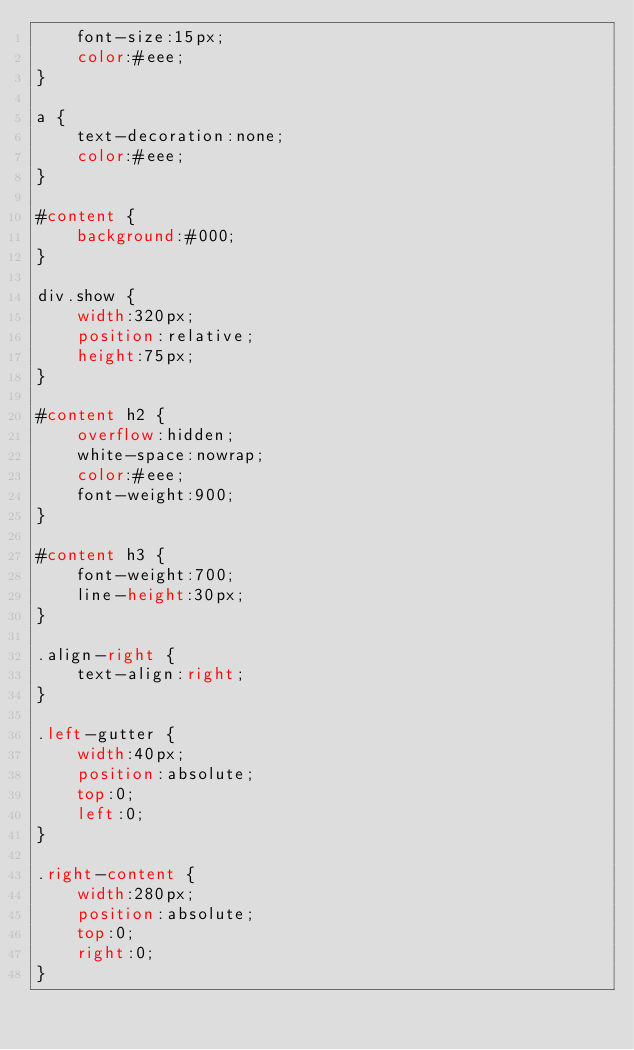<code> <loc_0><loc_0><loc_500><loc_500><_CSS_>    font-size:15px;
    color:#eee;
}

a {
    text-decoration:none;
    color:#eee;
}

#content {
    background:#000;
}

div.show {
    width:320px;
    position:relative;
    height:75px;
}

#content h2 {
    overflow:hidden;
    white-space:nowrap;
    color:#eee;
    font-weight:900;
}

#content h3 {
    font-weight:700;
    line-height:30px;
}

.align-right {
    text-align:right;
}

.left-gutter {
    width:40px;
    position:absolute;
    top:0;
    left:0;
}

.right-content {
    width:280px;
    position:absolute;
    top:0;
    right:0;
}
</code> 